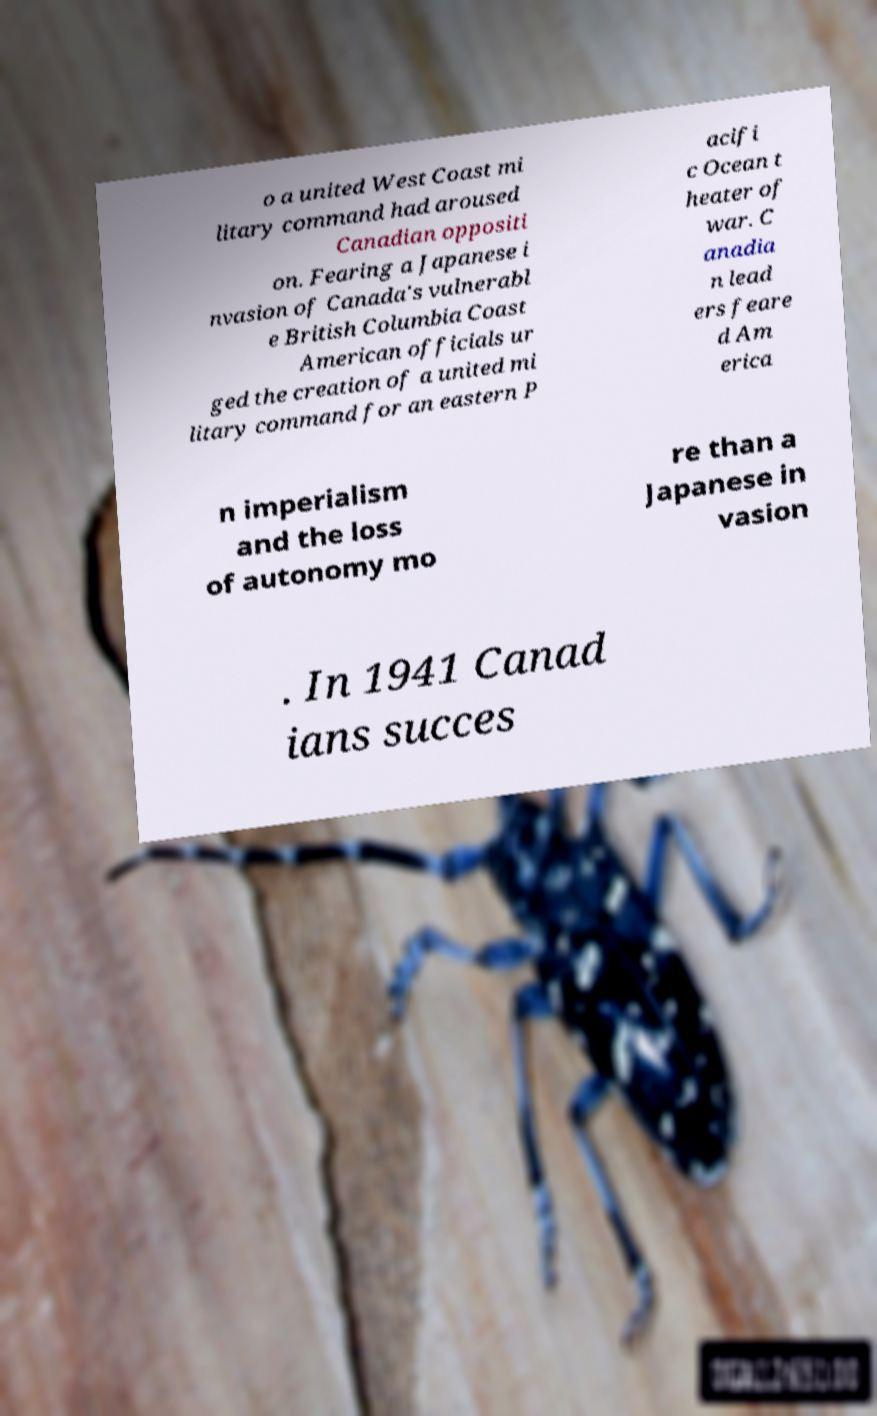Can you read and provide the text displayed in the image?This photo seems to have some interesting text. Can you extract and type it out for me? o a united West Coast mi litary command had aroused Canadian oppositi on. Fearing a Japanese i nvasion of Canada's vulnerabl e British Columbia Coast American officials ur ged the creation of a united mi litary command for an eastern P acifi c Ocean t heater of war. C anadia n lead ers feare d Am erica n imperialism and the loss of autonomy mo re than a Japanese in vasion . In 1941 Canad ians succes 